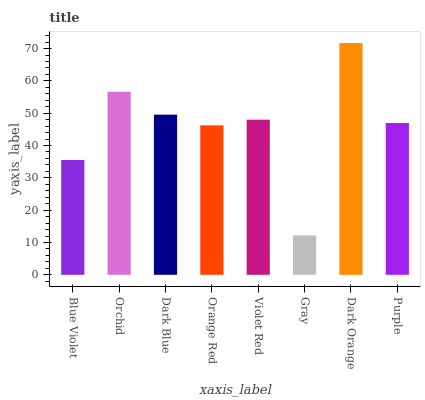Is Gray the minimum?
Answer yes or no. Yes. Is Dark Orange the maximum?
Answer yes or no. Yes. Is Orchid the minimum?
Answer yes or no. No. Is Orchid the maximum?
Answer yes or no. No. Is Orchid greater than Blue Violet?
Answer yes or no. Yes. Is Blue Violet less than Orchid?
Answer yes or no. Yes. Is Blue Violet greater than Orchid?
Answer yes or no. No. Is Orchid less than Blue Violet?
Answer yes or no. No. Is Violet Red the high median?
Answer yes or no. Yes. Is Purple the low median?
Answer yes or no. Yes. Is Dark Orange the high median?
Answer yes or no. No. Is Orange Red the low median?
Answer yes or no. No. 